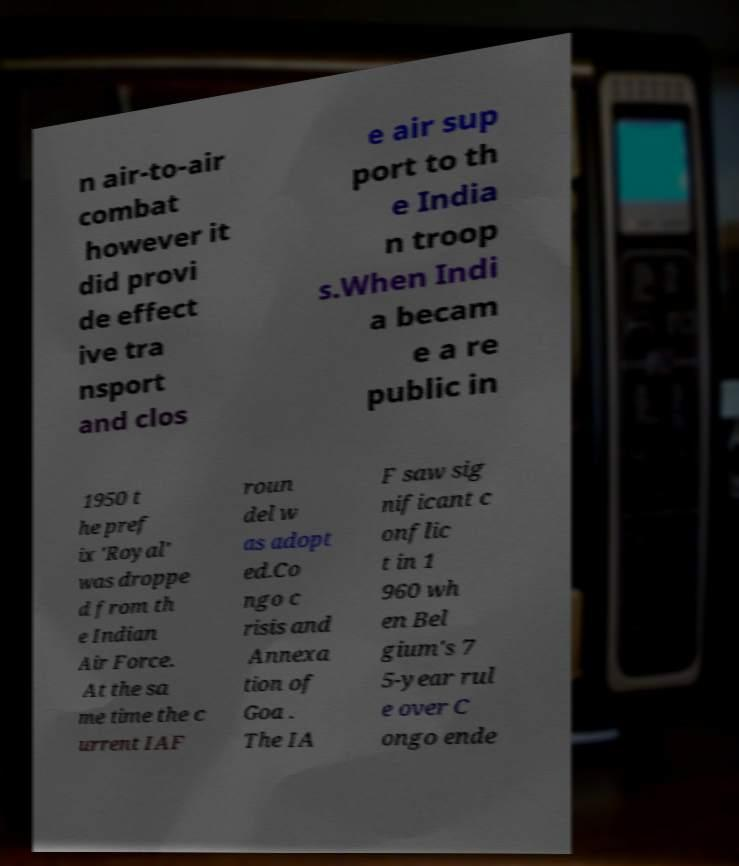Can you accurately transcribe the text from the provided image for me? n air-to-air combat however it did provi de effect ive tra nsport and clos e air sup port to th e India n troop s.When Indi a becam e a re public in 1950 t he pref ix 'Royal' was droppe d from th e Indian Air Force. At the sa me time the c urrent IAF roun del w as adopt ed.Co ngo c risis and Annexa tion of Goa . The IA F saw sig nificant c onflic t in 1 960 wh en Bel gium's 7 5-year rul e over C ongo ende 